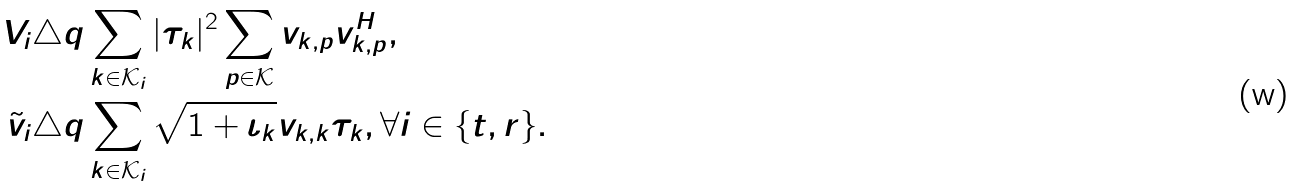<formula> <loc_0><loc_0><loc_500><loc_500>V _ { i } & \triangle q \sum _ { k \in \mathcal { K } _ { i } } | \tau _ { k } | ^ { 2 } \sum _ { p \in \mathcal { K } } v _ { k , p } v _ { k , p } ^ { H } , \\ \tilde { v } _ { i } & \triangle q \sum _ { k \in \mathcal { K } _ { i } } \sqrt { 1 + \iota _ { k } } v _ { k , k } \tau _ { k } , \forall i \in \{ t , r \} .</formula> 